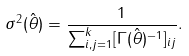Convert formula to latex. <formula><loc_0><loc_0><loc_500><loc_500>\sigma ^ { 2 } ( \hat { \theta } ) = \frac { 1 } { \sum _ { i , j = 1 } ^ { k } [ \Gamma ( \hat { \theta } ) ^ { - 1 } ] _ { i j } } .</formula> 